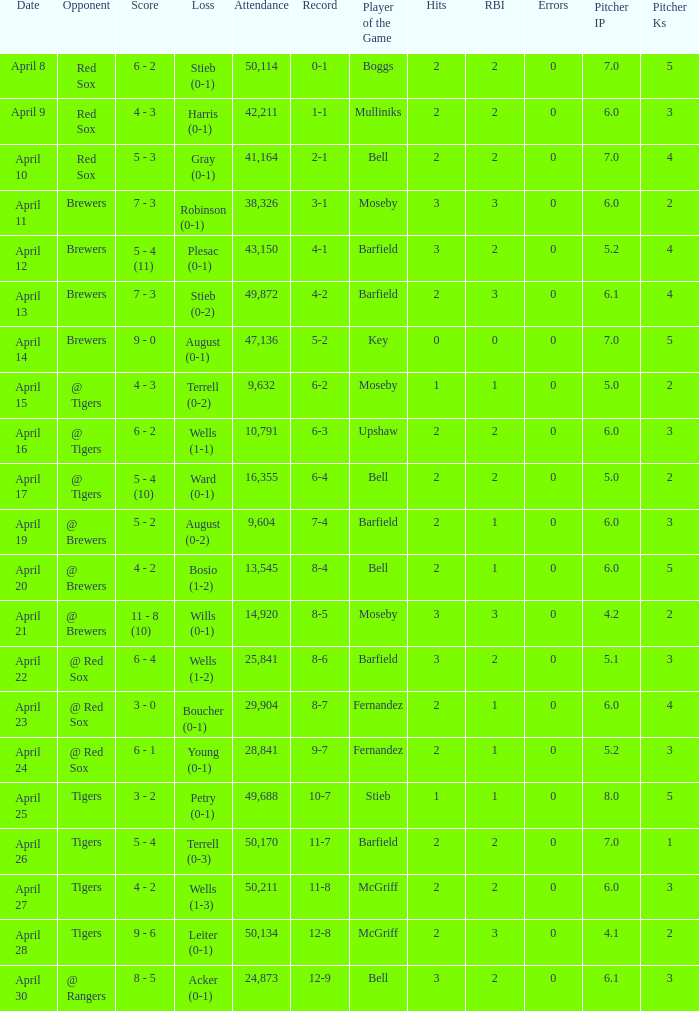Which loss has an attendance greater than 49,688 and 11-8 as the record? Wells (1-3). 